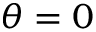Convert formula to latex. <formula><loc_0><loc_0><loc_500><loc_500>\theta = 0</formula> 